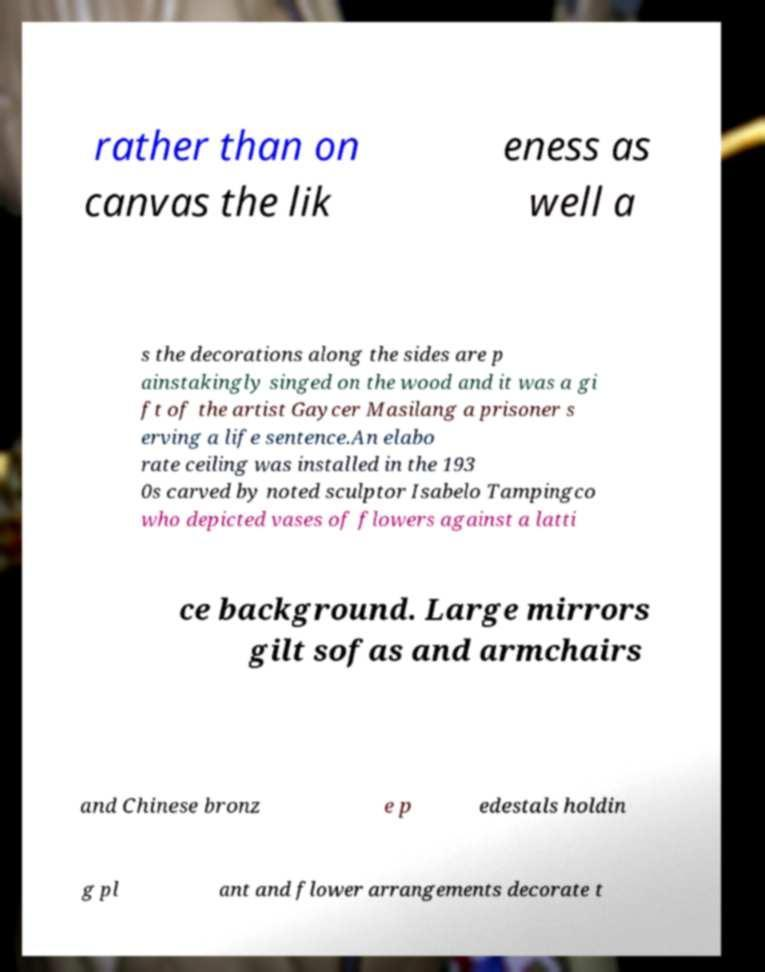What messages or text are displayed in this image? I need them in a readable, typed format. rather than on canvas the lik eness as well a s the decorations along the sides are p ainstakingly singed on the wood and it was a gi ft of the artist Gaycer Masilang a prisoner s erving a life sentence.An elabo rate ceiling was installed in the 193 0s carved by noted sculptor Isabelo Tampingco who depicted vases of flowers against a latti ce background. Large mirrors gilt sofas and armchairs and Chinese bronz e p edestals holdin g pl ant and flower arrangements decorate t 